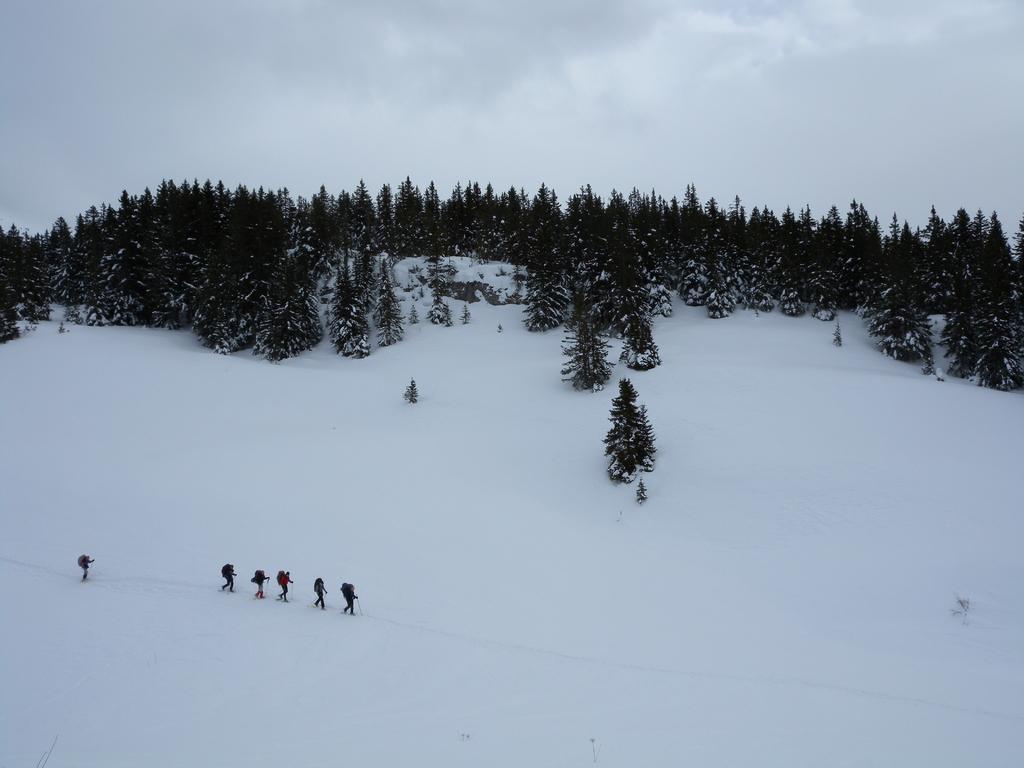Could you give a brief overview of what you see in this image? In the picture we can see a hill which is covered with full of snow on it, we can see some people are skating, wearing bags and on the top of the hill we can see trees and behind it we can see a sky with clouds. 